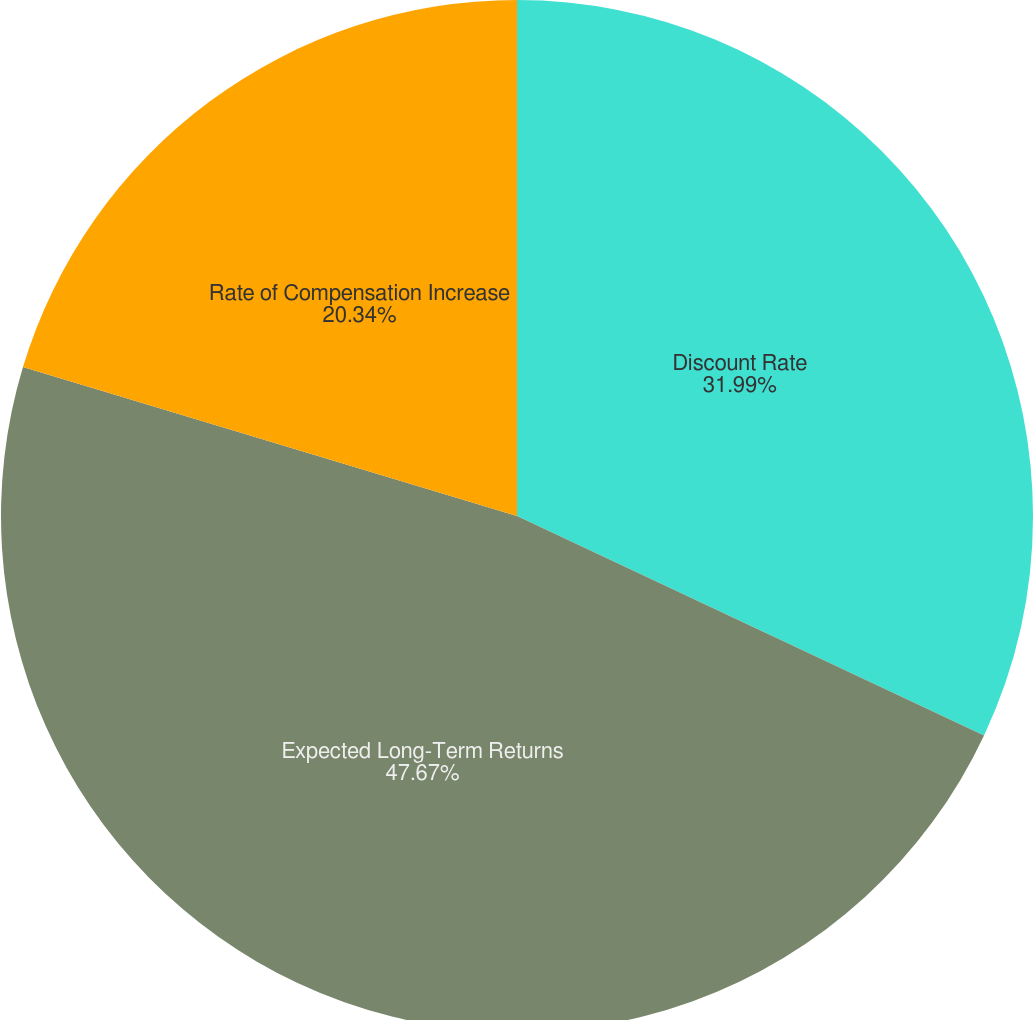<chart> <loc_0><loc_0><loc_500><loc_500><pie_chart><fcel>Discount Rate<fcel>Expected Long-Term Returns<fcel>Rate of Compensation Increase<nl><fcel>31.99%<fcel>47.67%<fcel>20.34%<nl></chart> 